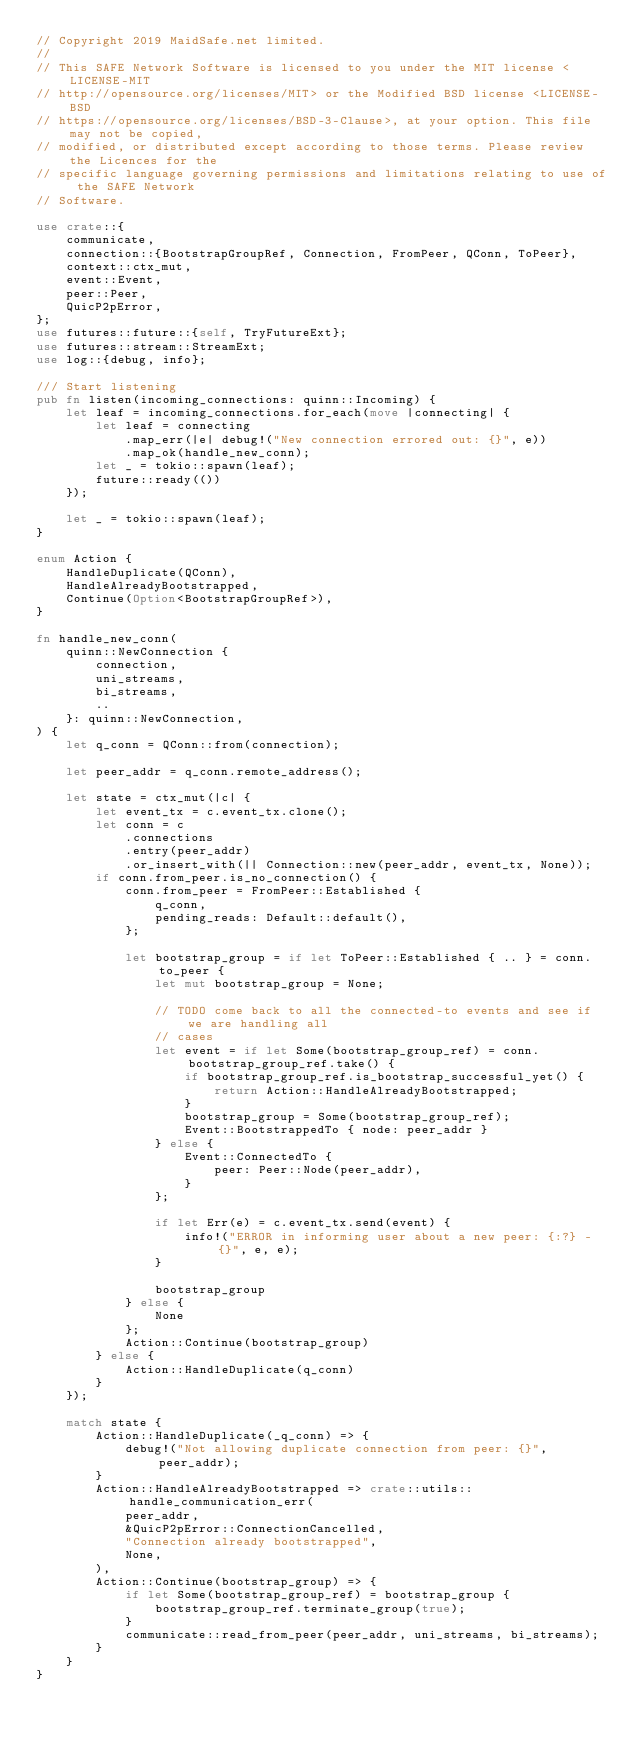<code> <loc_0><loc_0><loc_500><loc_500><_Rust_>// Copyright 2019 MaidSafe.net limited.
//
// This SAFE Network Software is licensed to you under the MIT license <LICENSE-MIT
// http://opensource.org/licenses/MIT> or the Modified BSD license <LICENSE-BSD
// https://opensource.org/licenses/BSD-3-Clause>, at your option. This file may not be copied,
// modified, or distributed except according to those terms. Please review the Licences for the
// specific language governing permissions and limitations relating to use of the SAFE Network
// Software.

use crate::{
    communicate,
    connection::{BootstrapGroupRef, Connection, FromPeer, QConn, ToPeer},
    context::ctx_mut,
    event::Event,
    peer::Peer,
    QuicP2pError,
};
use futures::future::{self, TryFutureExt};
use futures::stream::StreamExt;
use log::{debug, info};

/// Start listening
pub fn listen(incoming_connections: quinn::Incoming) {
    let leaf = incoming_connections.for_each(move |connecting| {
        let leaf = connecting
            .map_err(|e| debug!("New connection errored out: {}", e))
            .map_ok(handle_new_conn);
        let _ = tokio::spawn(leaf);
        future::ready(())
    });

    let _ = tokio::spawn(leaf);
}

enum Action {
    HandleDuplicate(QConn),
    HandleAlreadyBootstrapped,
    Continue(Option<BootstrapGroupRef>),
}

fn handle_new_conn(
    quinn::NewConnection {
        connection,
        uni_streams,
        bi_streams,
        ..
    }: quinn::NewConnection,
) {
    let q_conn = QConn::from(connection);

    let peer_addr = q_conn.remote_address();

    let state = ctx_mut(|c| {
        let event_tx = c.event_tx.clone();
        let conn = c
            .connections
            .entry(peer_addr)
            .or_insert_with(|| Connection::new(peer_addr, event_tx, None));
        if conn.from_peer.is_no_connection() {
            conn.from_peer = FromPeer::Established {
                q_conn,
                pending_reads: Default::default(),
            };

            let bootstrap_group = if let ToPeer::Established { .. } = conn.to_peer {
                let mut bootstrap_group = None;

                // TODO come back to all the connected-to events and see if we are handling all
                // cases
                let event = if let Some(bootstrap_group_ref) = conn.bootstrap_group_ref.take() {
                    if bootstrap_group_ref.is_bootstrap_successful_yet() {
                        return Action::HandleAlreadyBootstrapped;
                    }
                    bootstrap_group = Some(bootstrap_group_ref);
                    Event::BootstrappedTo { node: peer_addr }
                } else {
                    Event::ConnectedTo {
                        peer: Peer::Node(peer_addr),
                    }
                };

                if let Err(e) = c.event_tx.send(event) {
                    info!("ERROR in informing user about a new peer: {:?} - {}", e, e);
                }

                bootstrap_group
            } else {
                None
            };
            Action::Continue(bootstrap_group)
        } else {
            Action::HandleDuplicate(q_conn)
        }
    });

    match state {
        Action::HandleDuplicate(_q_conn) => {
            debug!("Not allowing duplicate connection from peer: {}", peer_addr);
        }
        Action::HandleAlreadyBootstrapped => crate::utils::handle_communication_err(
            peer_addr,
            &QuicP2pError::ConnectionCancelled,
            "Connection already bootstrapped",
            None,
        ),
        Action::Continue(bootstrap_group) => {
            if let Some(bootstrap_group_ref) = bootstrap_group {
                bootstrap_group_ref.terminate_group(true);
            }
            communicate::read_from_peer(peer_addr, uni_streams, bi_streams);
        }
    }
}
</code> 